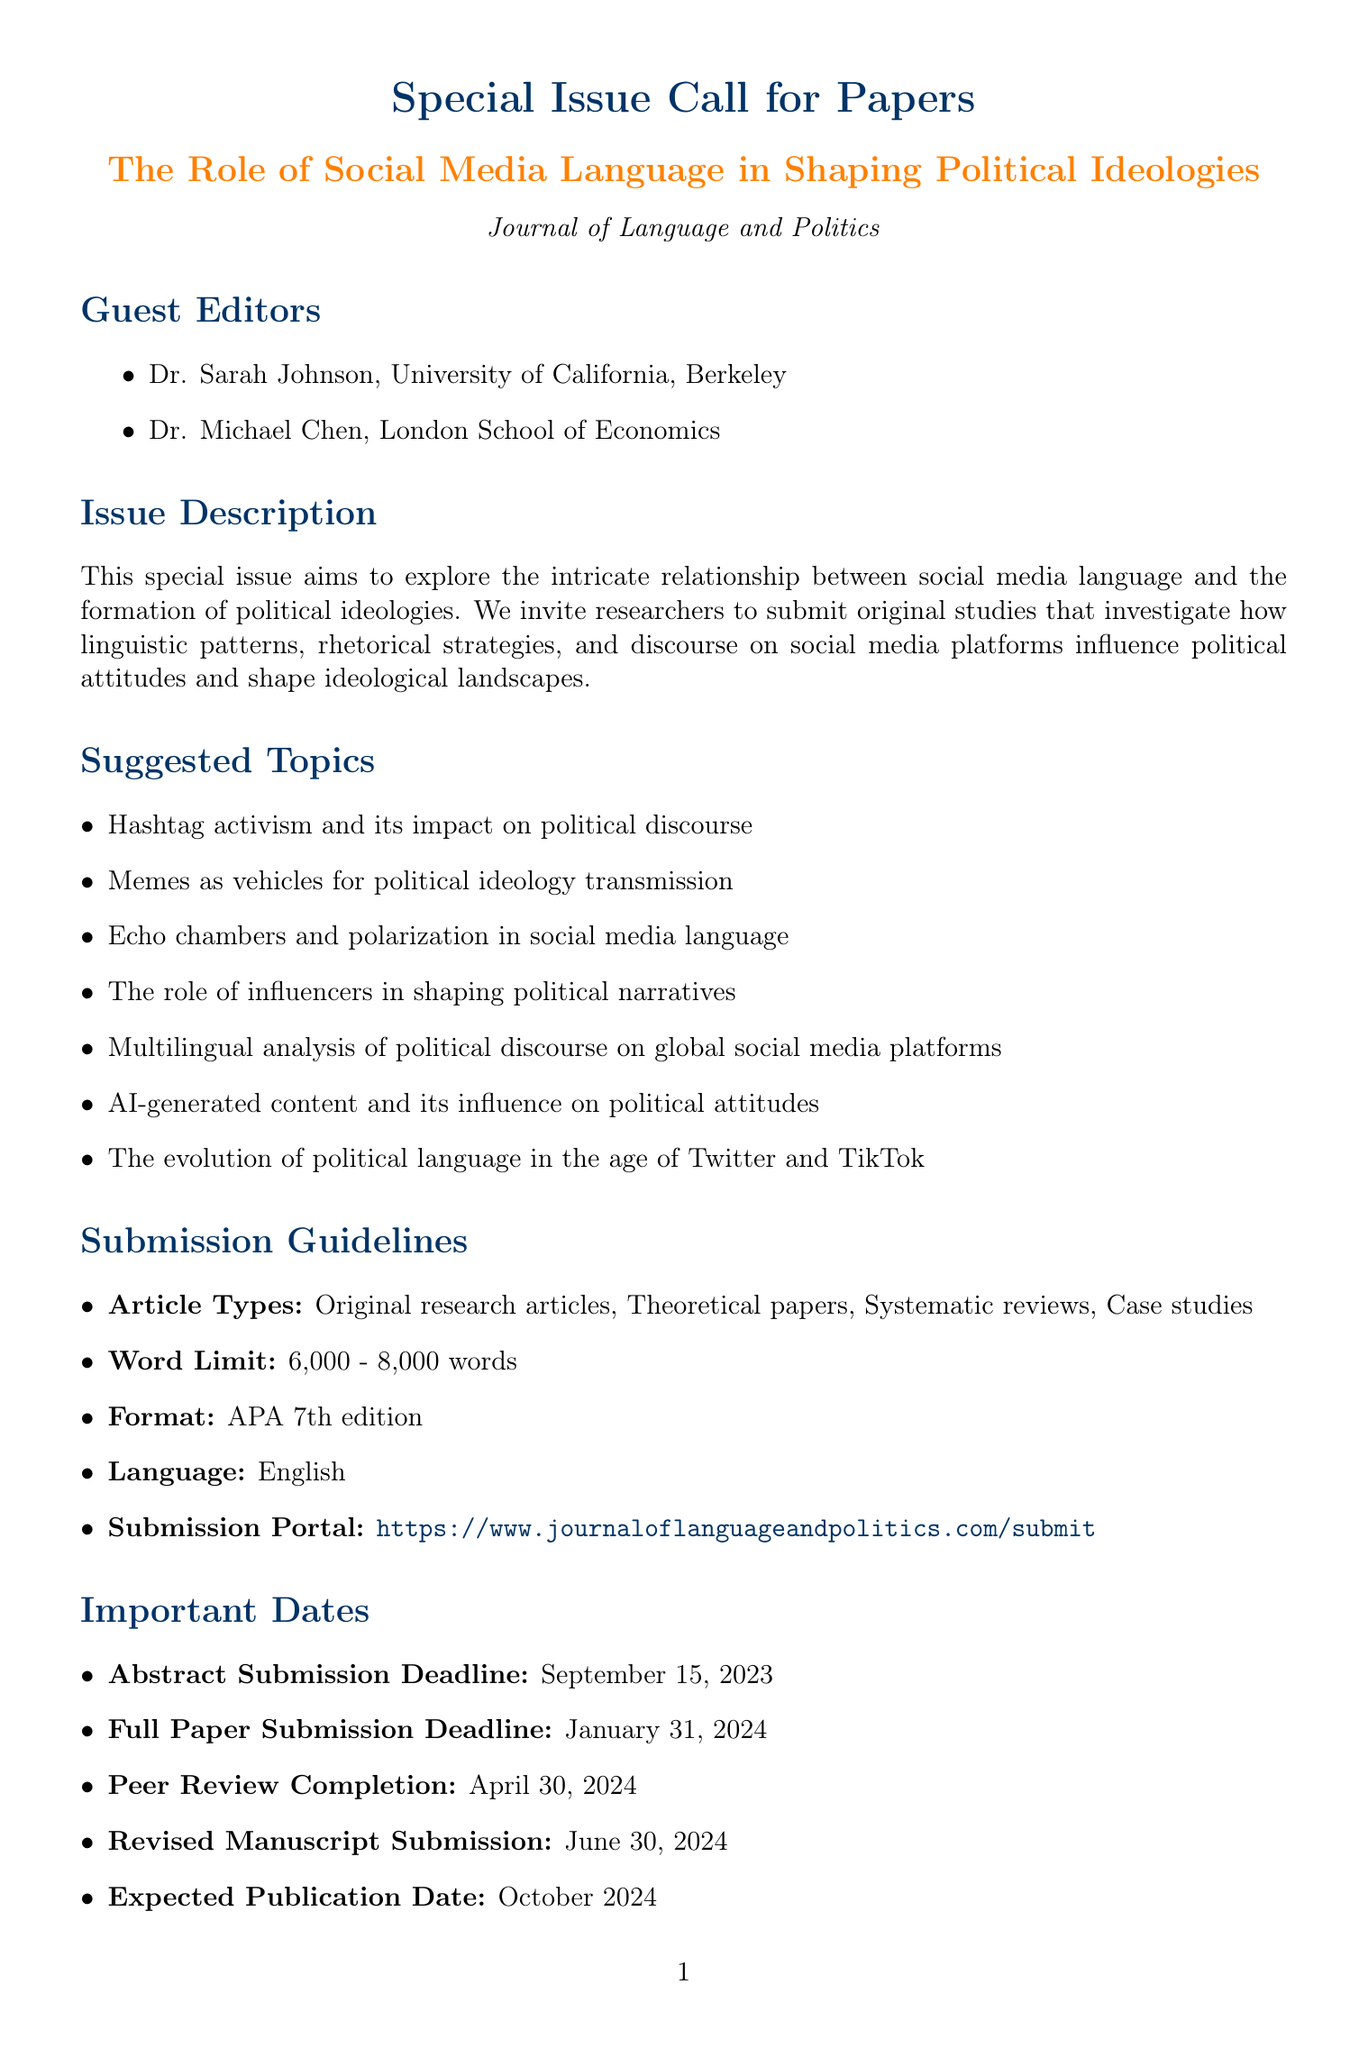what is the title of the special issue? The title is provided in the document and is specifically stated under the special issue section.
Answer: The Role of Social Media Language in Shaping Political Ideologies who are the guest editors? The guest editors are listed in the document with their names and affiliations.
Answer: Dr. Sarah Johnson, Dr. Michael Chen what is the abstract submission deadline? The document clearly states the important dates, including the abstract submission deadline.
Answer: September 15, 2023 what type of manuscripts are accepted for submission? The submission guidelines section mentions the article types that are accepted for this special issue.
Answer: Original research articles, Theoretical papers, Systematic reviews, Case studies what is the maximum word limit for the articles? The word limit is specified in the submission guidelines for the articles submitted to the special issue.
Answer: 8000 what is the expected publication date of the special issue? The expected publication date is mentioned in the important dates section of the document.
Answer: October 2024 what role do memes play in political ideology according to suggested topics? The suggested topics outline how various factors influence political ideologies, specifically mentioning memes.
Answer: Memes as vehicles for political ideology transmission when is the webinar on preparing manuscripts scheduled? The additional resources section includes details of the webinar, including the date.
Answer: August 1, 2023 which social media platform is associated with the hashtag #SocialMediaPolitics2024? The document mentions this hashtag in the social media promotion section.
Answer: Twitter 